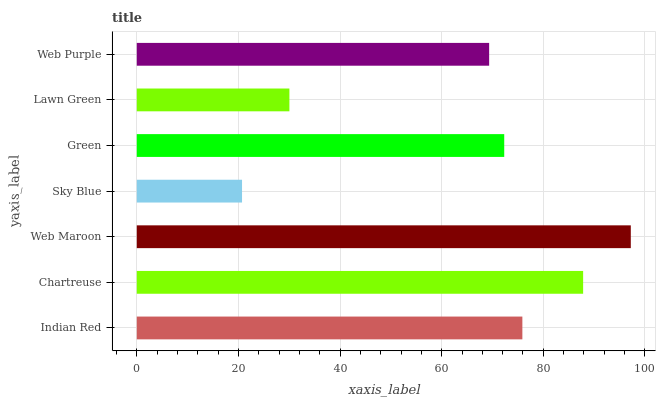Is Sky Blue the minimum?
Answer yes or no. Yes. Is Web Maroon the maximum?
Answer yes or no. Yes. Is Chartreuse the minimum?
Answer yes or no. No. Is Chartreuse the maximum?
Answer yes or no. No. Is Chartreuse greater than Indian Red?
Answer yes or no. Yes. Is Indian Red less than Chartreuse?
Answer yes or no. Yes. Is Indian Red greater than Chartreuse?
Answer yes or no. No. Is Chartreuse less than Indian Red?
Answer yes or no. No. Is Green the high median?
Answer yes or no. Yes. Is Green the low median?
Answer yes or no. Yes. Is Indian Red the high median?
Answer yes or no. No. Is Web Purple the low median?
Answer yes or no. No. 